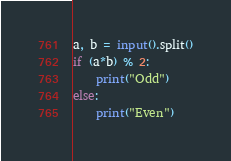Convert code to text. <code><loc_0><loc_0><loc_500><loc_500><_Python_>a, b = input().split()
if (a*b) % 2:
    print("Odd")
else:
    print("Even")</code> 